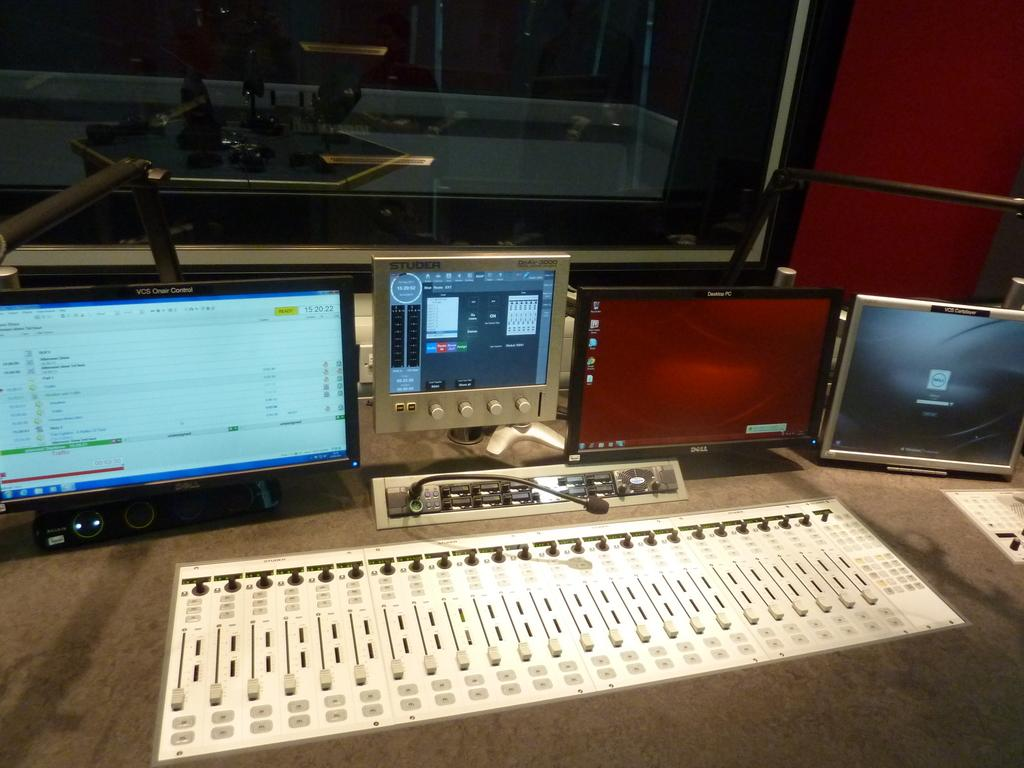<image>
Present a compact description of the photo's key features. A sound studio board and a Studer instrument panel. 